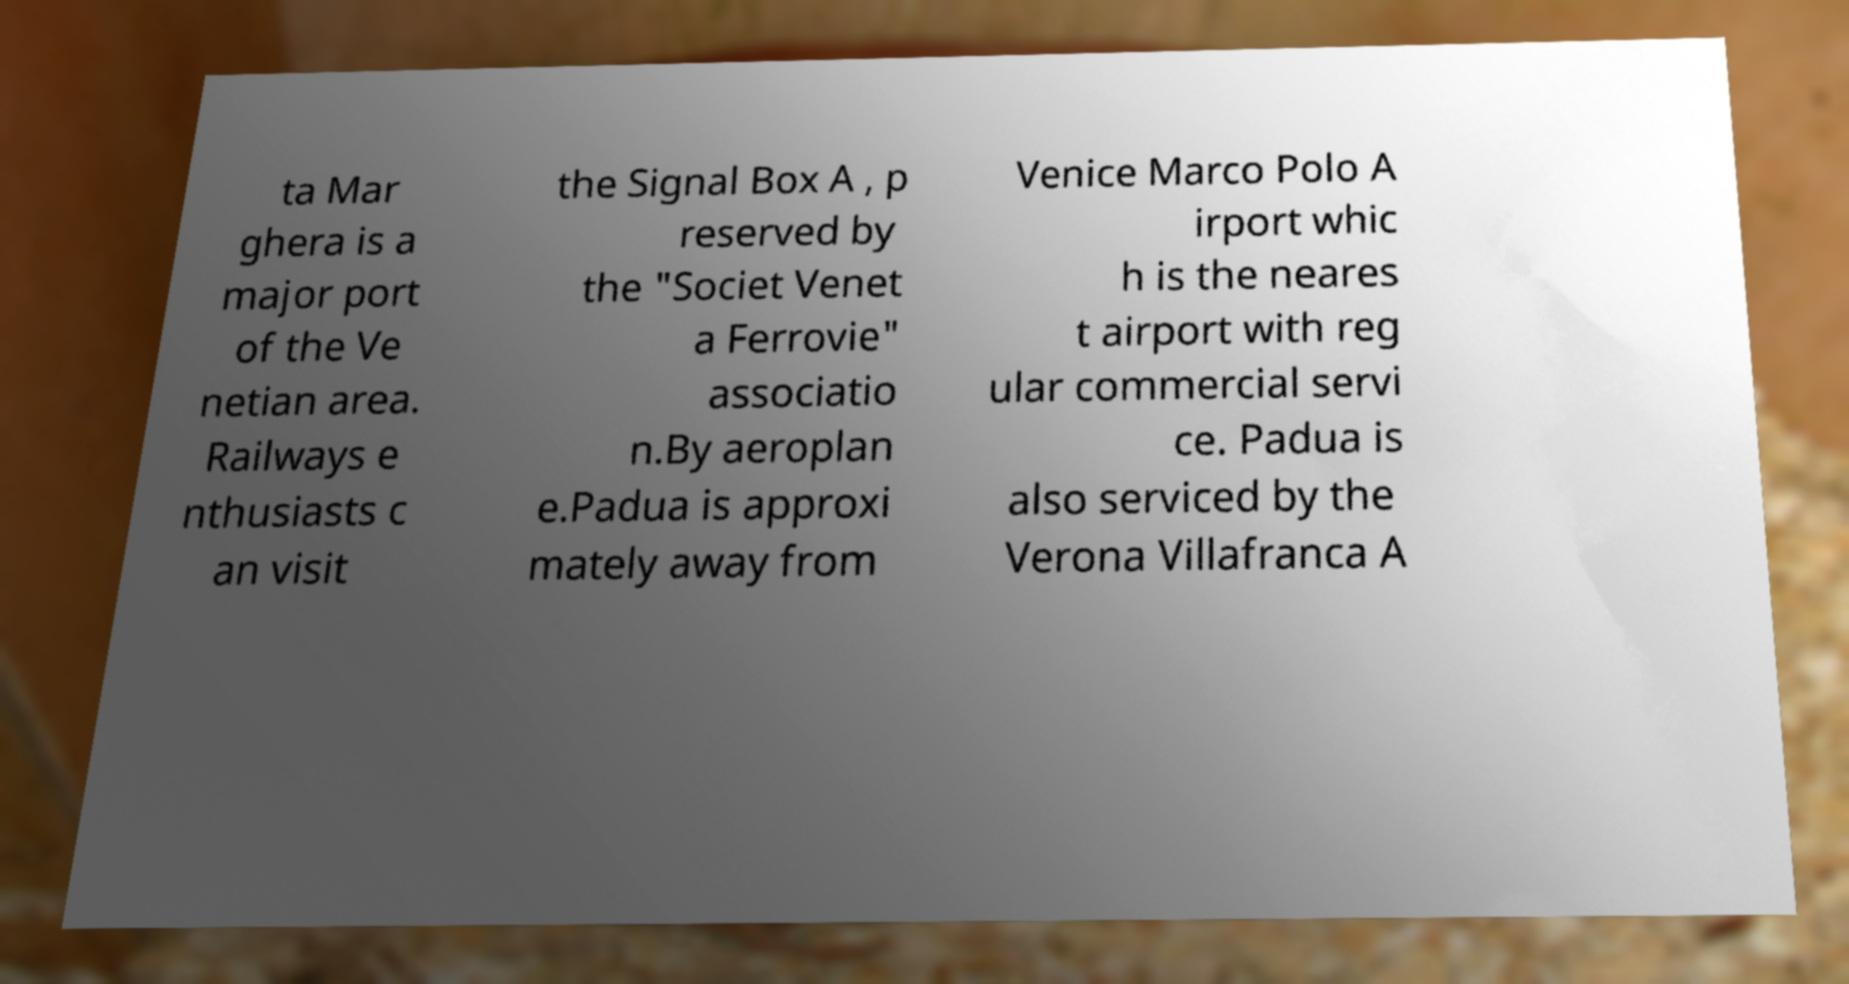Could you assist in decoding the text presented in this image and type it out clearly? ta Mar ghera is a major port of the Ve netian area. Railways e nthusiasts c an visit the Signal Box A , p reserved by the "Societ Venet a Ferrovie" associatio n.By aeroplan e.Padua is approxi mately away from Venice Marco Polo A irport whic h is the neares t airport with reg ular commercial servi ce. Padua is also serviced by the Verona Villafranca A 